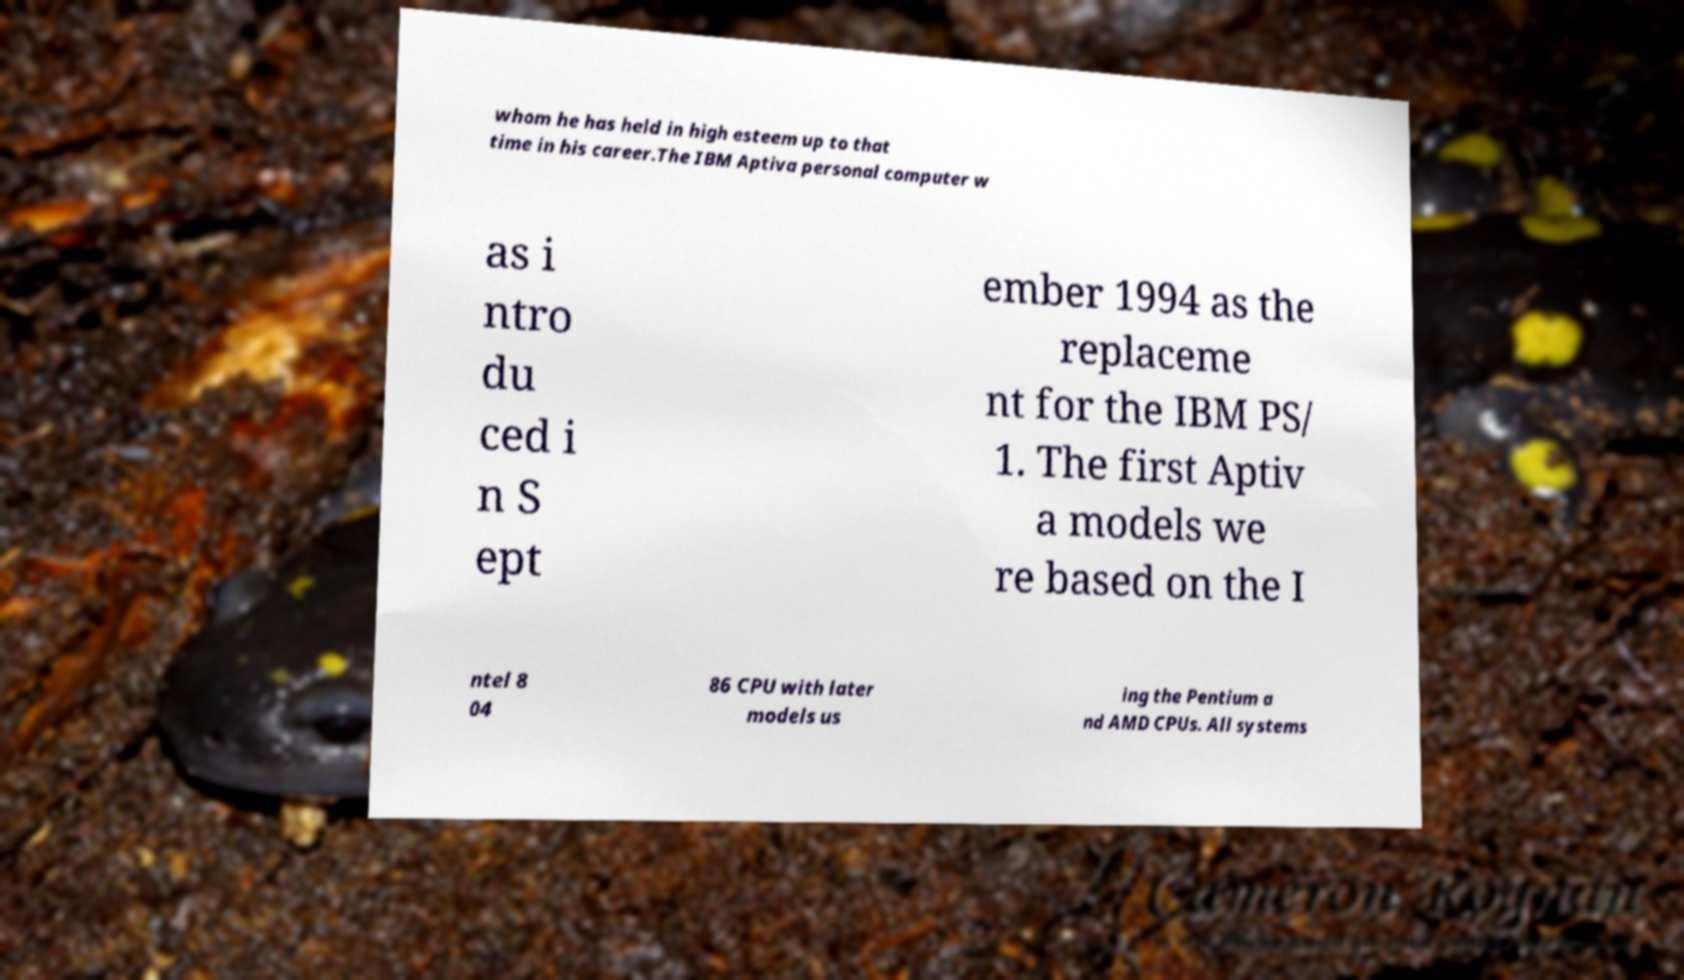Could you extract and type out the text from this image? whom he has held in high esteem up to that time in his career.The IBM Aptiva personal computer w as i ntro du ced i n S ept ember 1994 as the replaceme nt for the IBM PS/ 1. The first Aptiv a models we re based on the I ntel 8 04 86 CPU with later models us ing the Pentium a nd AMD CPUs. All systems 